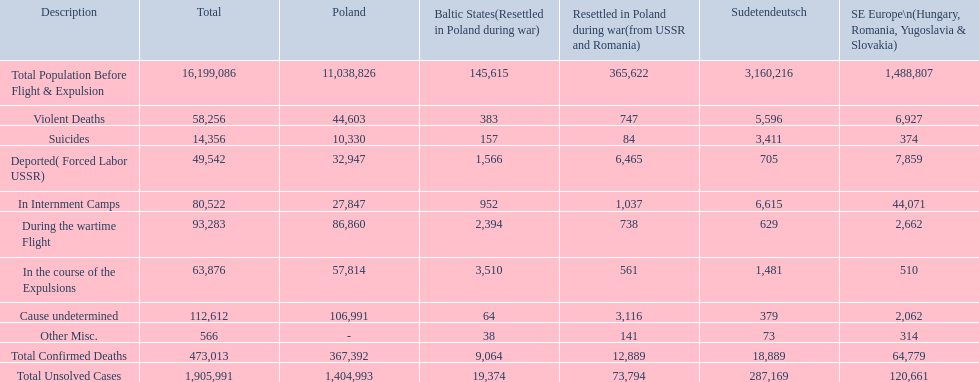What is the sum of all validated deaths in the baltic regions? 9,064. How many deaths had an unspecified reason? 64. How many deaths in that territory were assorted? 38. Were there more deaths with an unknown cause or those labeled as miscellaneous? Cause undetermined. 